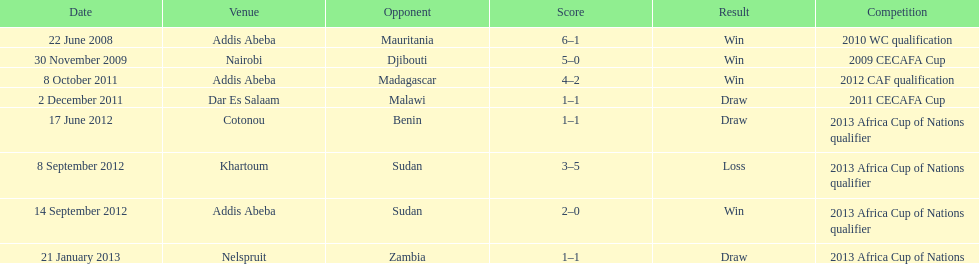How long in years down this table cover? 5. 